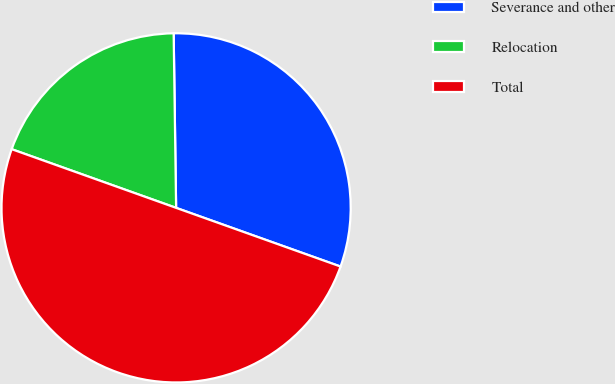Convert chart to OTSL. <chart><loc_0><loc_0><loc_500><loc_500><pie_chart><fcel>Severance and other<fcel>Relocation<fcel>Total<nl><fcel>30.68%<fcel>19.32%<fcel>50.0%<nl></chart> 